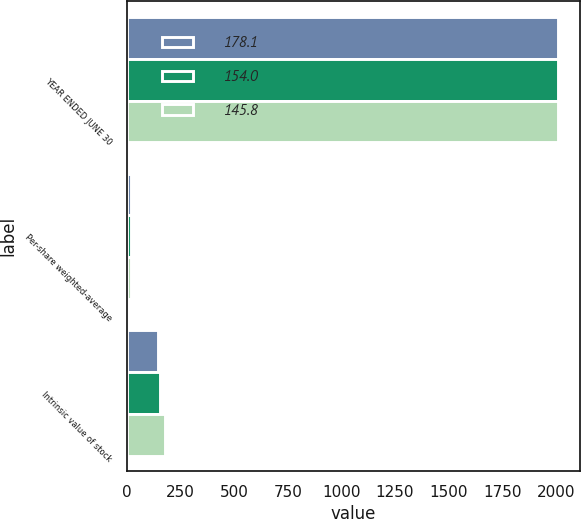Convert chart. <chart><loc_0><loc_0><loc_500><loc_500><stacked_bar_chart><ecel><fcel>YEAR ENDED JUNE 30<fcel>Per-share weighted-average<fcel>Intrinsic value of stock<nl><fcel>178.1<fcel>2013<fcel>20.3<fcel>145.8<nl><fcel>154<fcel>2012<fcel>17.41<fcel>154<nl><fcel>145.8<fcel>2011<fcel>18.93<fcel>178.1<nl></chart> 